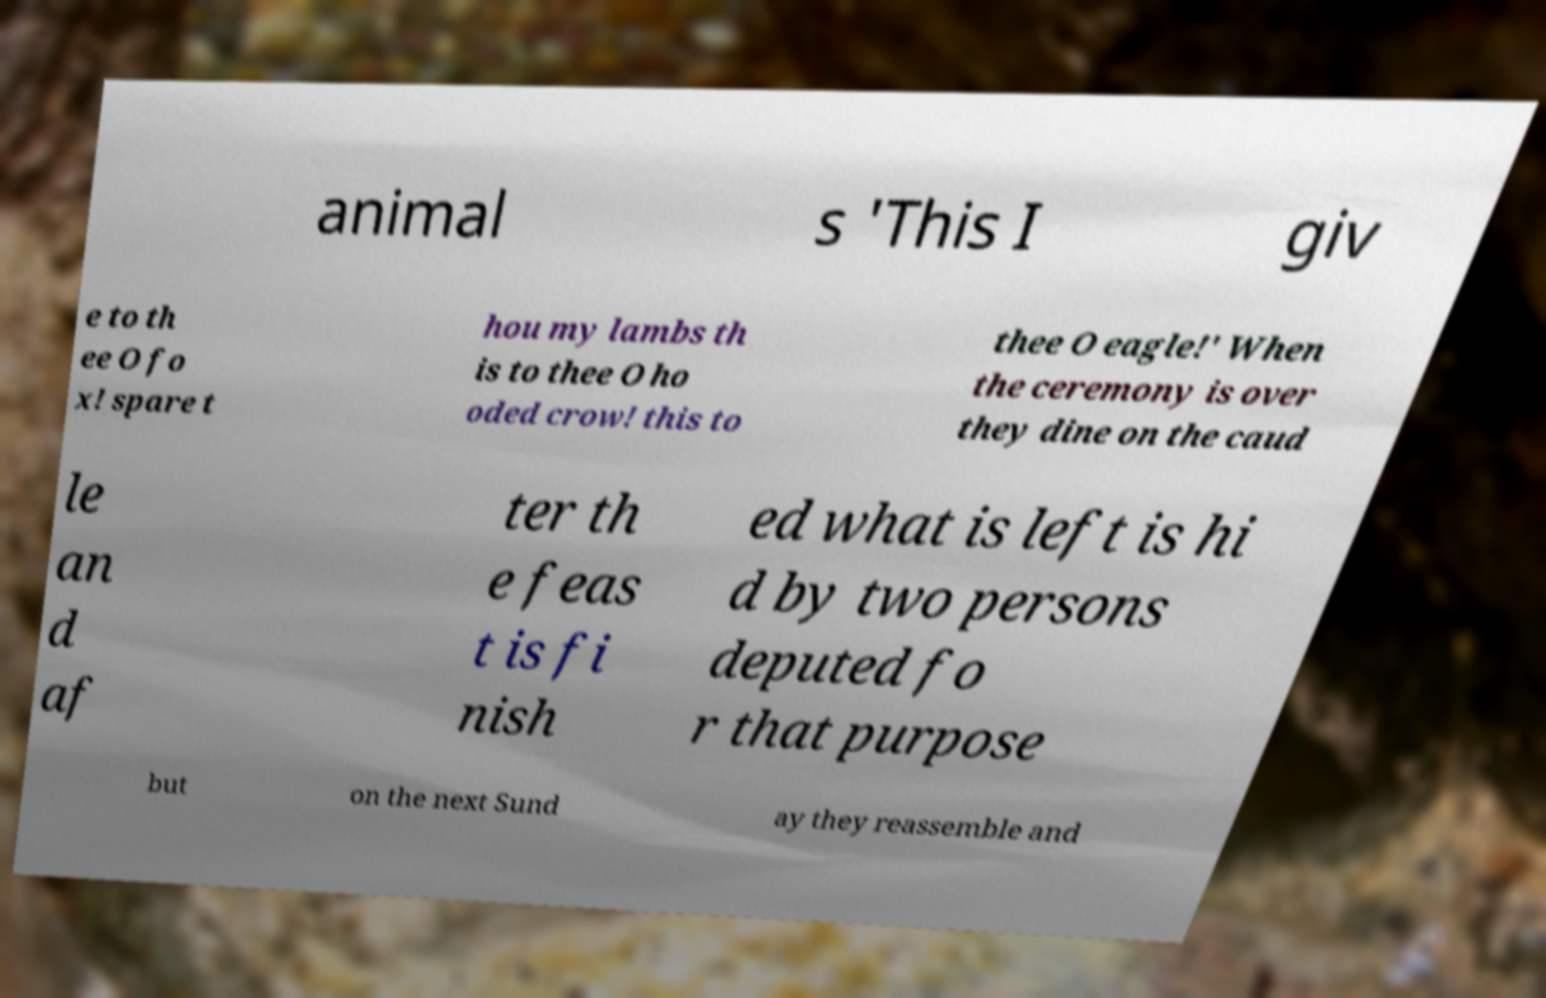For documentation purposes, I need the text within this image transcribed. Could you provide that? animal s 'This I giv e to th ee O fo x! spare t hou my lambs th is to thee O ho oded crow! this to thee O eagle!' When the ceremony is over they dine on the caud le an d af ter th e feas t is fi nish ed what is left is hi d by two persons deputed fo r that purpose but on the next Sund ay they reassemble and 